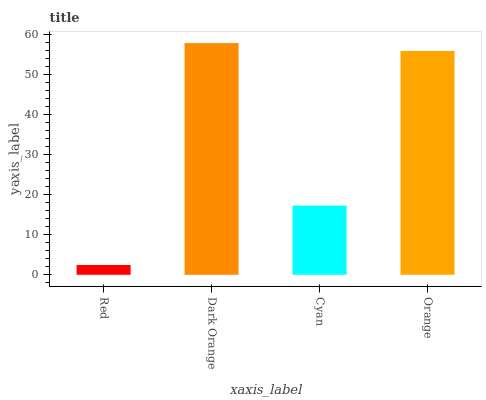Is Red the minimum?
Answer yes or no. Yes. Is Dark Orange the maximum?
Answer yes or no. Yes. Is Cyan the minimum?
Answer yes or no. No. Is Cyan the maximum?
Answer yes or no. No. Is Dark Orange greater than Cyan?
Answer yes or no. Yes. Is Cyan less than Dark Orange?
Answer yes or no. Yes. Is Cyan greater than Dark Orange?
Answer yes or no. No. Is Dark Orange less than Cyan?
Answer yes or no. No. Is Orange the high median?
Answer yes or no. Yes. Is Cyan the low median?
Answer yes or no. Yes. Is Dark Orange the high median?
Answer yes or no. No. Is Dark Orange the low median?
Answer yes or no. No. 